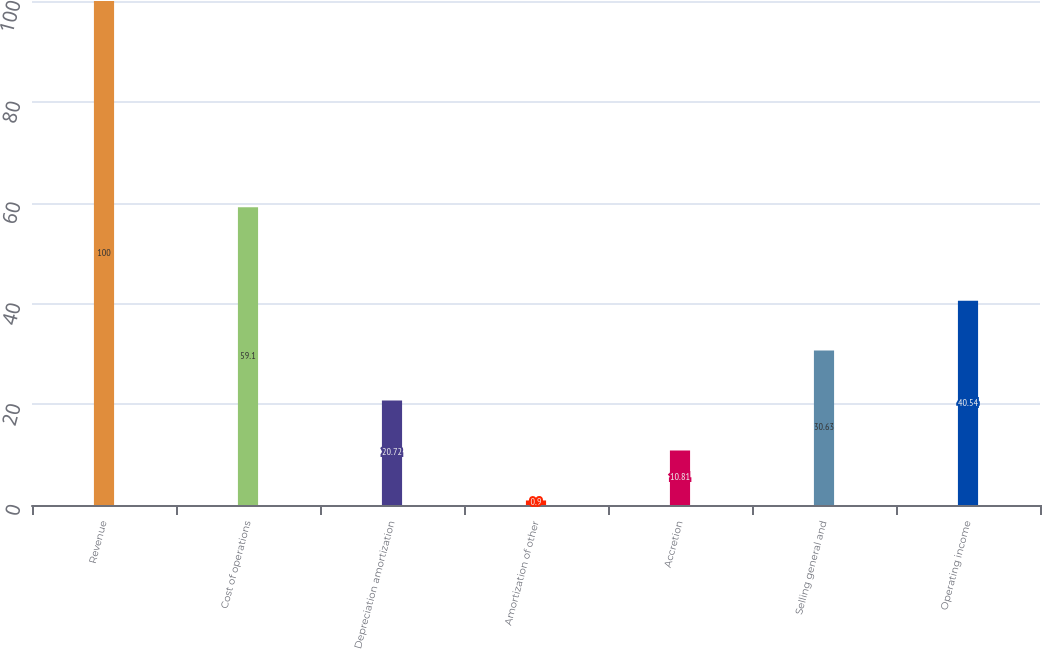Convert chart. <chart><loc_0><loc_0><loc_500><loc_500><bar_chart><fcel>Revenue<fcel>Cost of operations<fcel>Depreciation amortization<fcel>Amortization of other<fcel>Accretion<fcel>Selling general and<fcel>Operating income<nl><fcel>100<fcel>59.1<fcel>20.72<fcel>0.9<fcel>10.81<fcel>30.63<fcel>40.54<nl></chart> 